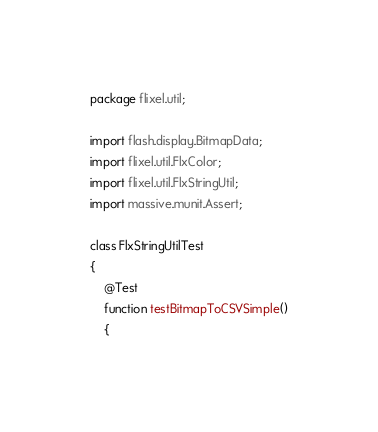Convert code to text. <code><loc_0><loc_0><loc_500><loc_500><_Haxe_>package flixel.util;

import flash.display.BitmapData;
import flixel.util.FlxColor;
import flixel.util.FlxStringUtil;
import massive.munit.Assert;

class FlxStringUtilTest
{
	@Test
	function testBitmapToCSVSimple()
	{</code> 